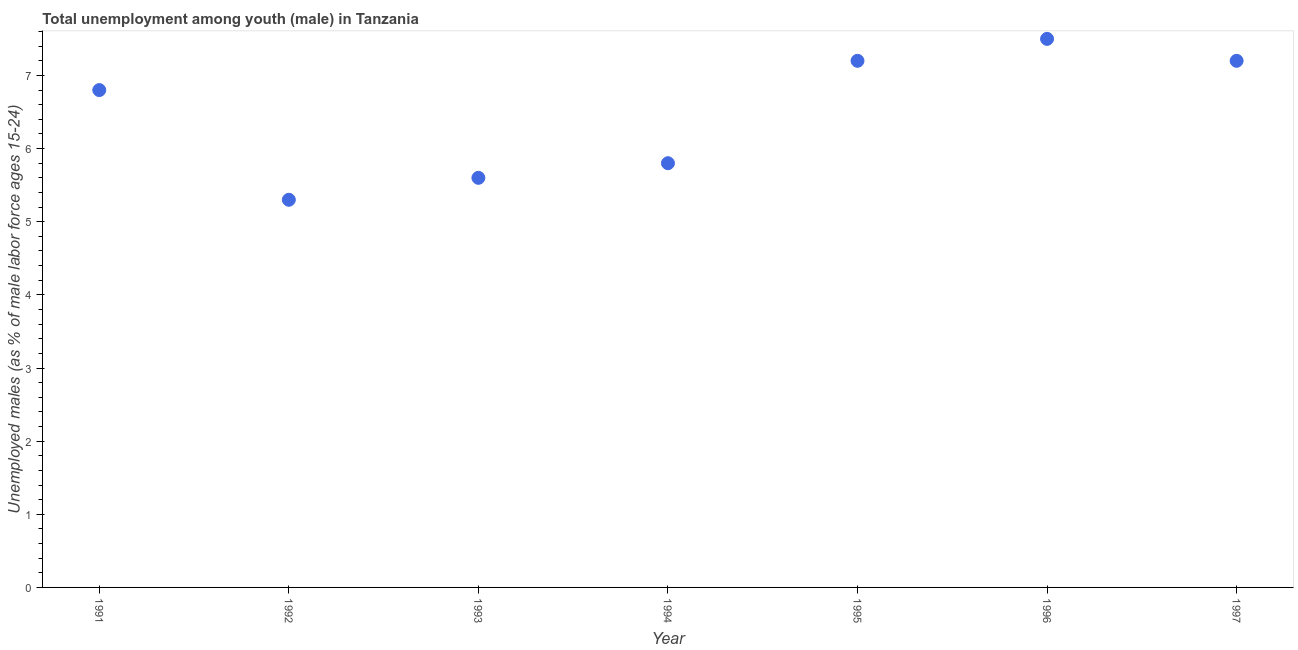What is the unemployed male youth population in 1997?
Provide a succinct answer. 7.2. Across all years, what is the maximum unemployed male youth population?
Your answer should be compact. 7.5. Across all years, what is the minimum unemployed male youth population?
Keep it short and to the point. 5.3. In which year was the unemployed male youth population maximum?
Your answer should be compact. 1996. In which year was the unemployed male youth population minimum?
Offer a very short reply. 1992. What is the sum of the unemployed male youth population?
Your answer should be very brief. 45.4. What is the difference between the unemployed male youth population in 1993 and 1997?
Give a very brief answer. -1.6. What is the average unemployed male youth population per year?
Give a very brief answer. 6.49. What is the median unemployed male youth population?
Your answer should be very brief. 6.8. What is the ratio of the unemployed male youth population in 1992 to that in 1993?
Ensure brevity in your answer.  0.95. Is the unemployed male youth population in 1991 less than that in 1994?
Make the answer very short. No. Is the difference between the unemployed male youth population in 1995 and 1997 greater than the difference between any two years?
Make the answer very short. No. What is the difference between the highest and the second highest unemployed male youth population?
Provide a short and direct response. 0.3. Is the sum of the unemployed male youth population in 1994 and 1996 greater than the maximum unemployed male youth population across all years?
Give a very brief answer. Yes. What is the difference between the highest and the lowest unemployed male youth population?
Your answer should be compact. 2.2. Does the unemployed male youth population monotonically increase over the years?
Ensure brevity in your answer.  No. How many dotlines are there?
Provide a short and direct response. 1. What is the title of the graph?
Make the answer very short. Total unemployment among youth (male) in Tanzania. What is the label or title of the X-axis?
Ensure brevity in your answer.  Year. What is the label or title of the Y-axis?
Provide a short and direct response. Unemployed males (as % of male labor force ages 15-24). What is the Unemployed males (as % of male labor force ages 15-24) in 1991?
Make the answer very short. 6.8. What is the Unemployed males (as % of male labor force ages 15-24) in 1992?
Make the answer very short. 5.3. What is the Unemployed males (as % of male labor force ages 15-24) in 1993?
Keep it short and to the point. 5.6. What is the Unemployed males (as % of male labor force ages 15-24) in 1994?
Your answer should be very brief. 5.8. What is the Unemployed males (as % of male labor force ages 15-24) in 1995?
Offer a terse response. 7.2. What is the Unemployed males (as % of male labor force ages 15-24) in 1996?
Your response must be concise. 7.5. What is the Unemployed males (as % of male labor force ages 15-24) in 1997?
Your answer should be very brief. 7.2. What is the difference between the Unemployed males (as % of male labor force ages 15-24) in 1991 and 1992?
Keep it short and to the point. 1.5. What is the difference between the Unemployed males (as % of male labor force ages 15-24) in 1991 and 1997?
Your response must be concise. -0.4. What is the difference between the Unemployed males (as % of male labor force ages 15-24) in 1992 and 1993?
Your response must be concise. -0.3. What is the difference between the Unemployed males (as % of male labor force ages 15-24) in 1993 and 1995?
Make the answer very short. -1.6. What is the difference between the Unemployed males (as % of male labor force ages 15-24) in 1993 and 1996?
Provide a short and direct response. -1.9. What is the difference between the Unemployed males (as % of male labor force ages 15-24) in 1993 and 1997?
Give a very brief answer. -1.6. What is the difference between the Unemployed males (as % of male labor force ages 15-24) in 1994 and 1995?
Make the answer very short. -1.4. What is the difference between the Unemployed males (as % of male labor force ages 15-24) in 1994 and 1996?
Offer a very short reply. -1.7. What is the difference between the Unemployed males (as % of male labor force ages 15-24) in 1994 and 1997?
Your answer should be very brief. -1.4. What is the difference between the Unemployed males (as % of male labor force ages 15-24) in 1995 and 1996?
Provide a succinct answer. -0.3. What is the difference between the Unemployed males (as % of male labor force ages 15-24) in 1995 and 1997?
Provide a short and direct response. 0. What is the ratio of the Unemployed males (as % of male labor force ages 15-24) in 1991 to that in 1992?
Your answer should be very brief. 1.28. What is the ratio of the Unemployed males (as % of male labor force ages 15-24) in 1991 to that in 1993?
Your answer should be very brief. 1.21. What is the ratio of the Unemployed males (as % of male labor force ages 15-24) in 1991 to that in 1994?
Your answer should be compact. 1.17. What is the ratio of the Unemployed males (as % of male labor force ages 15-24) in 1991 to that in 1995?
Give a very brief answer. 0.94. What is the ratio of the Unemployed males (as % of male labor force ages 15-24) in 1991 to that in 1996?
Ensure brevity in your answer.  0.91. What is the ratio of the Unemployed males (as % of male labor force ages 15-24) in 1991 to that in 1997?
Your answer should be compact. 0.94. What is the ratio of the Unemployed males (as % of male labor force ages 15-24) in 1992 to that in 1993?
Give a very brief answer. 0.95. What is the ratio of the Unemployed males (as % of male labor force ages 15-24) in 1992 to that in 1994?
Keep it short and to the point. 0.91. What is the ratio of the Unemployed males (as % of male labor force ages 15-24) in 1992 to that in 1995?
Offer a terse response. 0.74. What is the ratio of the Unemployed males (as % of male labor force ages 15-24) in 1992 to that in 1996?
Make the answer very short. 0.71. What is the ratio of the Unemployed males (as % of male labor force ages 15-24) in 1992 to that in 1997?
Your response must be concise. 0.74. What is the ratio of the Unemployed males (as % of male labor force ages 15-24) in 1993 to that in 1995?
Give a very brief answer. 0.78. What is the ratio of the Unemployed males (as % of male labor force ages 15-24) in 1993 to that in 1996?
Make the answer very short. 0.75. What is the ratio of the Unemployed males (as % of male labor force ages 15-24) in 1993 to that in 1997?
Give a very brief answer. 0.78. What is the ratio of the Unemployed males (as % of male labor force ages 15-24) in 1994 to that in 1995?
Keep it short and to the point. 0.81. What is the ratio of the Unemployed males (as % of male labor force ages 15-24) in 1994 to that in 1996?
Your answer should be compact. 0.77. What is the ratio of the Unemployed males (as % of male labor force ages 15-24) in 1994 to that in 1997?
Your answer should be very brief. 0.81. What is the ratio of the Unemployed males (as % of male labor force ages 15-24) in 1995 to that in 1996?
Offer a terse response. 0.96. What is the ratio of the Unemployed males (as % of male labor force ages 15-24) in 1995 to that in 1997?
Your answer should be very brief. 1. What is the ratio of the Unemployed males (as % of male labor force ages 15-24) in 1996 to that in 1997?
Keep it short and to the point. 1.04. 